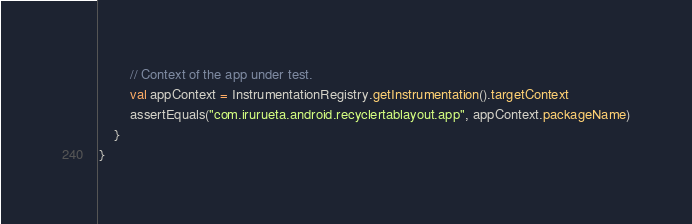Convert code to text. <code><loc_0><loc_0><loc_500><loc_500><_Kotlin_>        // Context of the app under test.
        val appContext = InstrumentationRegistry.getInstrumentation().targetContext
        assertEquals("com.irurueta.android.recyclertablayout.app", appContext.packageName)
    }
}</code> 